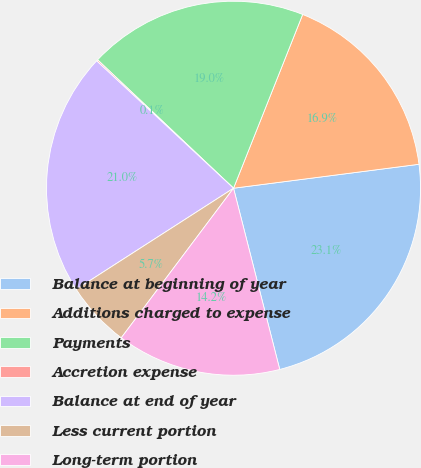Convert chart. <chart><loc_0><loc_0><loc_500><loc_500><pie_chart><fcel>Balance at beginning of year<fcel>Additions charged to expense<fcel>Payments<fcel>Accretion expense<fcel>Balance at end of year<fcel>Less current portion<fcel>Long-term portion<nl><fcel>23.07%<fcel>16.93%<fcel>18.98%<fcel>0.12%<fcel>21.02%<fcel>5.66%<fcel>14.22%<nl></chart> 